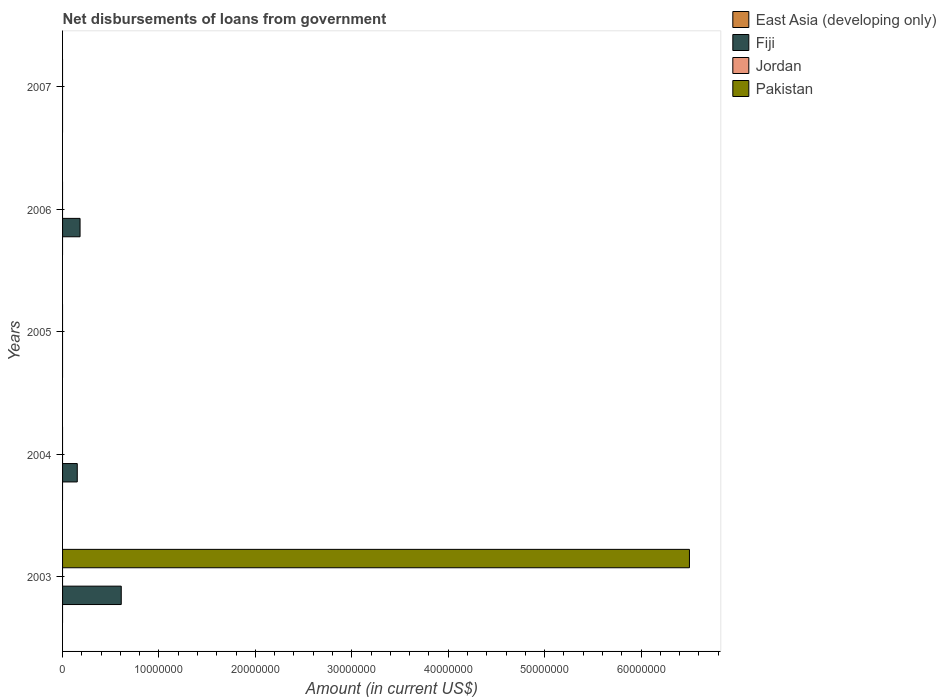Are the number of bars on each tick of the Y-axis equal?
Provide a short and direct response. No. How many bars are there on the 2nd tick from the top?
Give a very brief answer. 1. How many bars are there on the 2nd tick from the bottom?
Your answer should be very brief. 1. In how many cases, is the number of bars for a given year not equal to the number of legend labels?
Give a very brief answer. 5. Across all years, what is the maximum amount of loan disbursed from government in Fiji?
Offer a terse response. 6.09e+06. What is the total amount of loan disbursed from government in Jordan in the graph?
Provide a succinct answer. 0. What is the difference between the amount of loan disbursed from government in Fiji in 2003 and that in 2006?
Provide a short and direct response. 4.27e+06. What is the difference between the amount of loan disbursed from government in Fiji in 2004 and the amount of loan disbursed from government in Jordan in 2007?
Provide a succinct answer. 1.52e+06. What is the average amount of loan disbursed from government in Pakistan per year?
Keep it short and to the point. 1.30e+07. What is the difference between the highest and the second highest amount of loan disbursed from government in Fiji?
Provide a succinct answer. 4.27e+06. What is the difference between the highest and the lowest amount of loan disbursed from government in Fiji?
Provide a short and direct response. 6.09e+06. In how many years, is the amount of loan disbursed from government in East Asia (developing only) greater than the average amount of loan disbursed from government in East Asia (developing only) taken over all years?
Provide a succinct answer. 0. Is it the case that in every year, the sum of the amount of loan disbursed from government in Fiji and amount of loan disbursed from government in Pakistan is greater than the sum of amount of loan disbursed from government in Jordan and amount of loan disbursed from government in East Asia (developing only)?
Offer a very short reply. No. Are all the bars in the graph horizontal?
Your answer should be very brief. Yes. How many years are there in the graph?
Keep it short and to the point. 5. Does the graph contain any zero values?
Your answer should be compact. Yes. Does the graph contain grids?
Offer a terse response. No. How are the legend labels stacked?
Keep it short and to the point. Vertical. What is the title of the graph?
Your answer should be very brief. Net disbursements of loans from government. Does "Korea (Republic)" appear as one of the legend labels in the graph?
Make the answer very short. No. What is the label or title of the X-axis?
Provide a succinct answer. Amount (in current US$). What is the Amount (in current US$) in East Asia (developing only) in 2003?
Keep it short and to the point. 0. What is the Amount (in current US$) in Fiji in 2003?
Your answer should be compact. 6.09e+06. What is the Amount (in current US$) in Jordan in 2003?
Ensure brevity in your answer.  0. What is the Amount (in current US$) of Pakistan in 2003?
Ensure brevity in your answer.  6.50e+07. What is the Amount (in current US$) in Fiji in 2004?
Keep it short and to the point. 1.52e+06. What is the Amount (in current US$) of Pakistan in 2004?
Offer a terse response. 0. What is the Amount (in current US$) of Jordan in 2005?
Keep it short and to the point. 0. What is the Amount (in current US$) of Fiji in 2006?
Your answer should be compact. 1.81e+06. What is the Amount (in current US$) in Pakistan in 2007?
Your response must be concise. 0. Across all years, what is the maximum Amount (in current US$) in Fiji?
Keep it short and to the point. 6.09e+06. Across all years, what is the maximum Amount (in current US$) of Pakistan?
Your answer should be compact. 6.50e+07. Across all years, what is the minimum Amount (in current US$) of Pakistan?
Keep it short and to the point. 0. What is the total Amount (in current US$) in East Asia (developing only) in the graph?
Your answer should be compact. 0. What is the total Amount (in current US$) of Fiji in the graph?
Ensure brevity in your answer.  9.42e+06. What is the total Amount (in current US$) of Jordan in the graph?
Make the answer very short. 0. What is the total Amount (in current US$) of Pakistan in the graph?
Offer a very short reply. 6.50e+07. What is the difference between the Amount (in current US$) of Fiji in 2003 and that in 2004?
Your answer should be very brief. 4.56e+06. What is the difference between the Amount (in current US$) of Fiji in 2003 and that in 2006?
Provide a short and direct response. 4.27e+06. What is the average Amount (in current US$) in East Asia (developing only) per year?
Give a very brief answer. 0. What is the average Amount (in current US$) of Fiji per year?
Offer a terse response. 1.88e+06. What is the average Amount (in current US$) of Pakistan per year?
Your response must be concise. 1.30e+07. In the year 2003, what is the difference between the Amount (in current US$) of Fiji and Amount (in current US$) of Pakistan?
Provide a short and direct response. -5.89e+07. What is the ratio of the Amount (in current US$) of Fiji in 2003 to that in 2004?
Offer a terse response. 3.99. What is the ratio of the Amount (in current US$) of Fiji in 2003 to that in 2006?
Give a very brief answer. 3.35. What is the ratio of the Amount (in current US$) of Fiji in 2004 to that in 2006?
Ensure brevity in your answer.  0.84. What is the difference between the highest and the second highest Amount (in current US$) of Fiji?
Give a very brief answer. 4.27e+06. What is the difference between the highest and the lowest Amount (in current US$) in Fiji?
Make the answer very short. 6.09e+06. What is the difference between the highest and the lowest Amount (in current US$) of Pakistan?
Provide a succinct answer. 6.50e+07. 